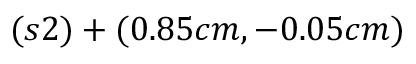Convert formula to latex. <formula><loc_0><loc_0><loc_500><loc_500>( s 2 ) + ( 0 . 8 5 c m , - 0 . 0 5 c m )</formula> 